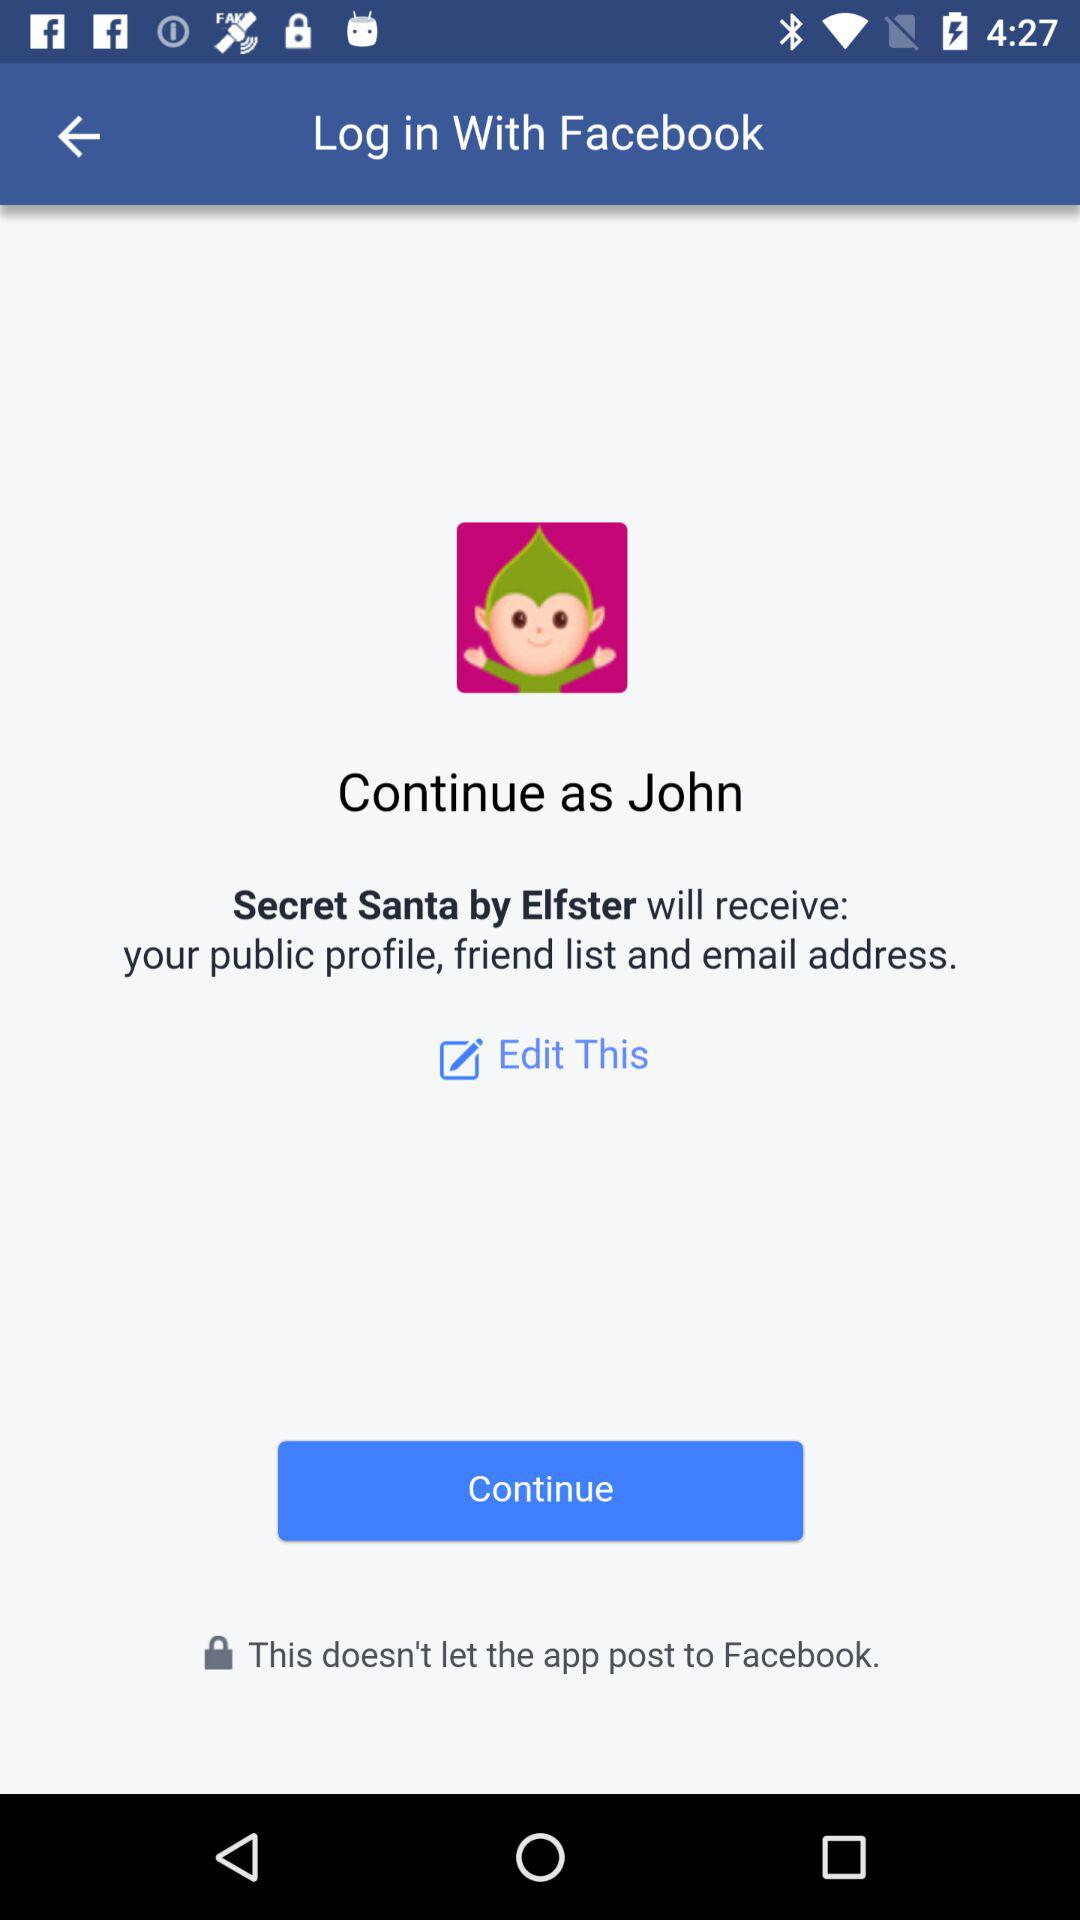Through what account login can be done? The account is "Facebook". 